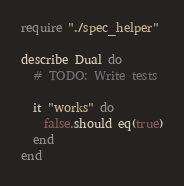Convert code to text. <code><loc_0><loc_0><loc_500><loc_500><_Crystal_>require "./spec_helper"

describe Dual do
  # TODO: Write tests

  it "works" do
    false.should eq(true)
  end
end
</code> 